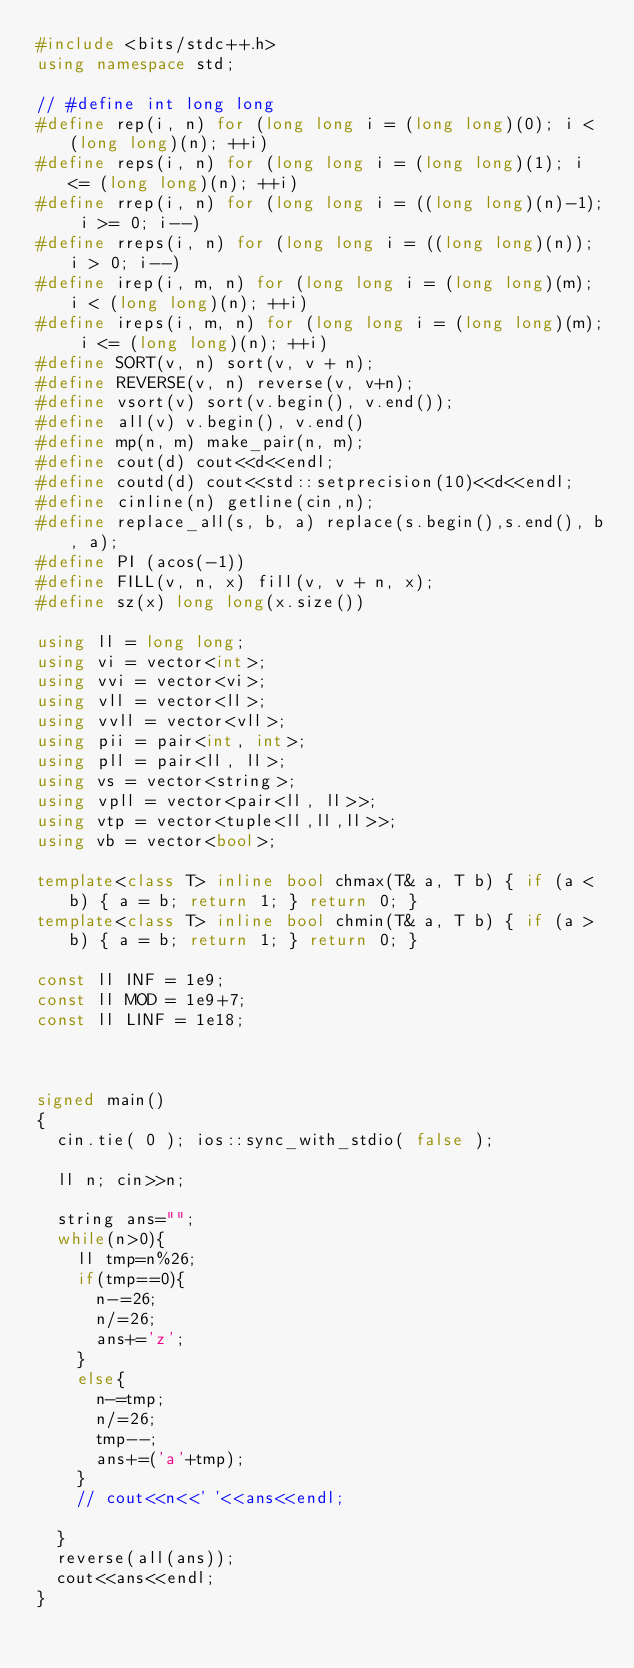Convert code to text. <code><loc_0><loc_0><loc_500><loc_500><_C++_>#include <bits/stdc++.h>
using namespace std;

// #define int long long
#define rep(i, n) for (long long i = (long long)(0); i < (long long)(n); ++i)
#define reps(i, n) for (long long i = (long long)(1); i <= (long long)(n); ++i)
#define rrep(i, n) for (long long i = ((long long)(n)-1); i >= 0; i--)
#define rreps(i, n) for (long long i = ((long long)(n)); i > 0; i--)
#define irep(i, m, n) for (long long i = (long long)(m); i < (long long)(n); ++i)
#define ireps(i, m, n) for (long long i = (long long)(m); i <= (long long)(n); ++i)
#define SORT(v, n) sort(v, v + n);
#define REVERSE(v, n) reverse(v, v+n);
#define vsort(v) sort(v.begin(), v.end());
#define all(v) v.begin(), v.end()
#define mp(n, m) make_pair(n, m);
#define cout(d) cout<<d<<endl;
#define coutd(d) cout<<std::setprecision(10)<<d<<endl;
#define cinline(n) getline(cin,n);
#define replace_all(s, b, a) replace(s.begin(),s.end(), b, a);
#define PI (acos(-1))
#define FILL(v, n, x) fill(v, v + n, x);
#define sz(x) long long(x.size())

using ll = long long;
using vi = vector<int>;
using vvi = vector<vi>;
using vll = vector<ll>;
using vvll = vector<vll>;
using pii = pair<int, int>;
using pll = pair<ll, ll>;
using vs = vector<string>;
using vpll = vector<pair<ll, ll>>;
using vtp = vector<tuple<ll,ll,ll>>;
using vb = vector<bool>;

template<class T> inline bool chmax(T& a, T b) { if (a < b) { a = b; return 1; } return 0; }
template<class T> inline bool chmin(T& a, T b) { if (a > b) { a = b; return 1; } return 0; }

const ll INF = 1e9;
const ll MOD = 1e9+7;
const ll LINF = 1e18;



signed main()
{
  cin.tie( 0 ); ios::sync_with_stdio( false );
  
  ll n; cin>>n;
  
  string ans="";
  while(n>0){
    ll tmp=n%26;
    if(tmp==0){
      n-=26;
      n/=26;
      ans+='z';
    }
    else{
      n-=tmp;
      n/=26;
      tmp--;
      ans+=('a'+tmp);
    }
    // cout<<n<<' '<<ans<<endl;
    
  }
  reverse(all(ans));
  cout<<ans<<endl;
}</code> 